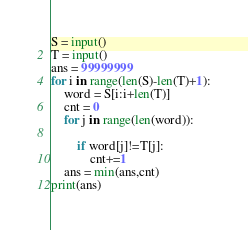<code> <loc_0><loc_0><loc_500><loc_500><_Python_>S = input()
T = input()
ans = 99999999
for i in range(len(S)-len(T)+1):
    word = S[i:i+len(T)]
    cnt = 0
    for j in range(len(word)):

        if word[j]!=T[j]:
            cnt+=1
    ans = min(ans,cnt)
print(ans)</code> 